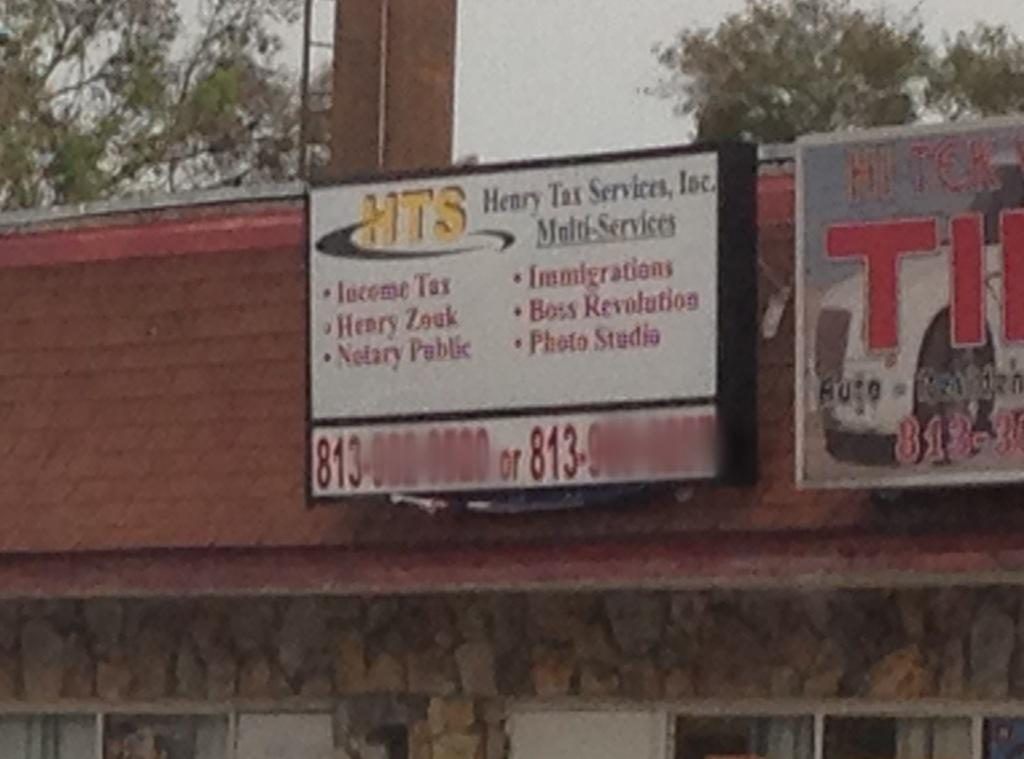Provide a one-sentence caption for the provided image. A Henry Tax Service Inc billboard on a an angled shop roof advertises multiple services. 